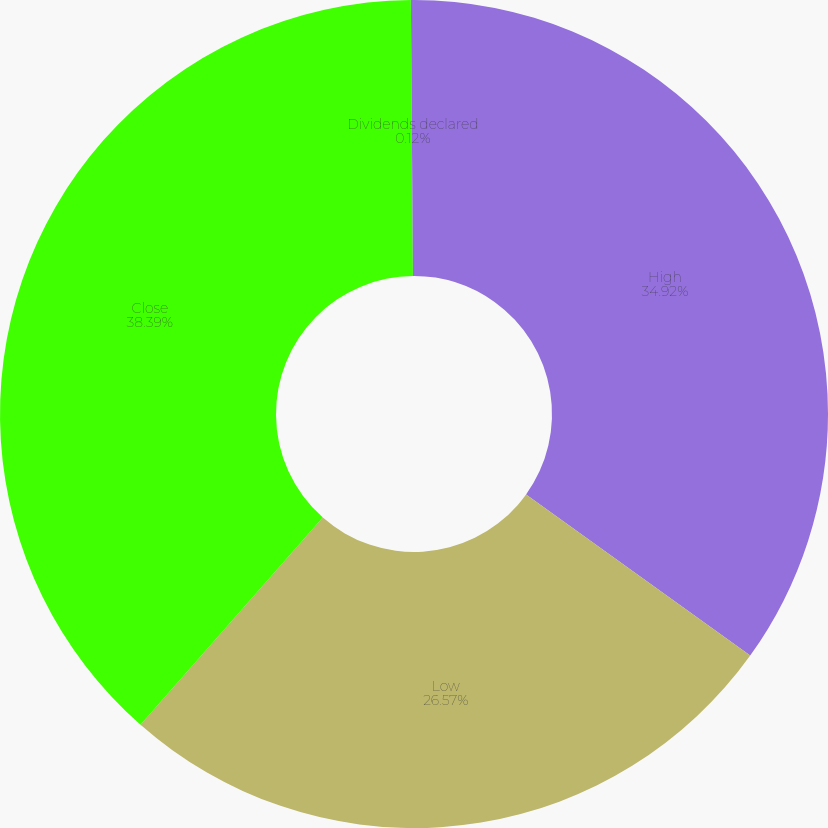<chart> <loc_0><loc_0><loc_500><loc_500><pie_chart><fcel>High<fcel>Low<fcel>Close<fcel>Dividends declared<nl><fcel>34.92%<fcel>26.57%<fcel>38.4%<fcel>0.12%<nl></chart> 